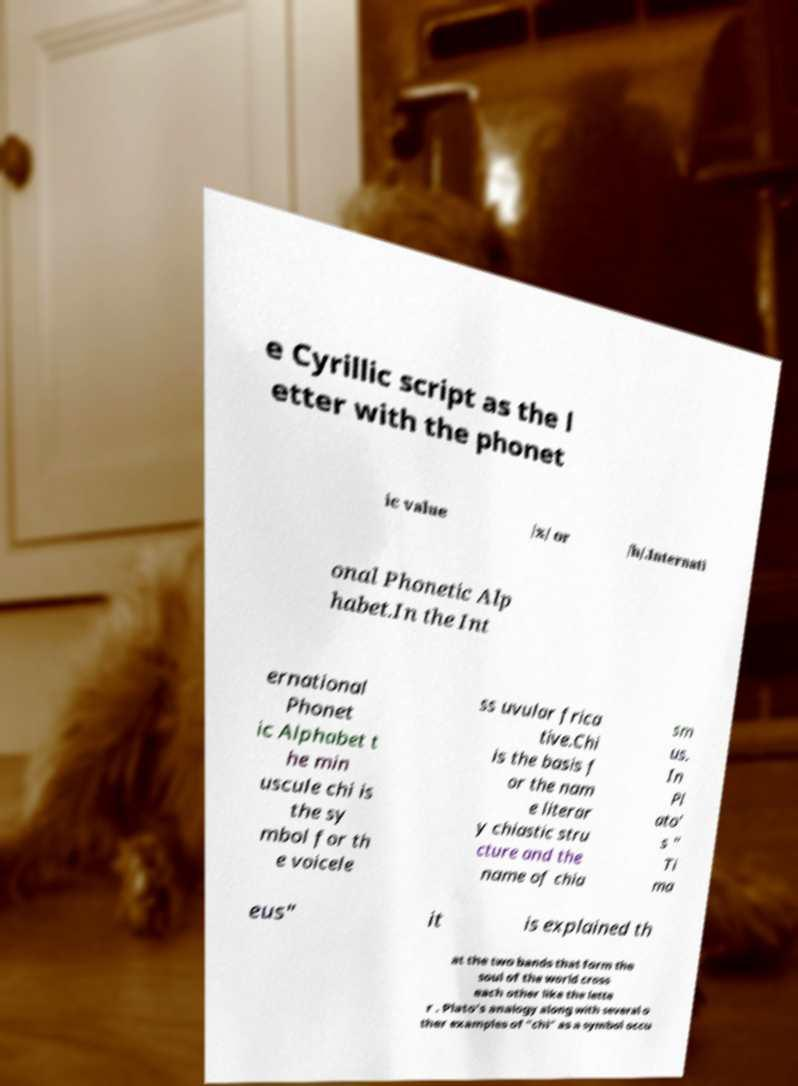Could you assist in decoding the text presented in this image and type it out clearly? e Cyrillic script as the l etter with the phonet ic value /x/ or /h/.Internati onal Phonetic Alp habet.In the Int ernational Phonet ic Alphabet t he min uscule chi is the sy mbol for th e voicele ss uvular frica tive.Chi is the basis f or the nam e literar y chiastic stru cture and the name of chia sm us. In Pl ato' s " Ti ma eus" it is explained th at the two bands that form the soul of the world cross each other like the lette r . Plato's analogy along with several o ther examples of "chi" as a symbol occu 